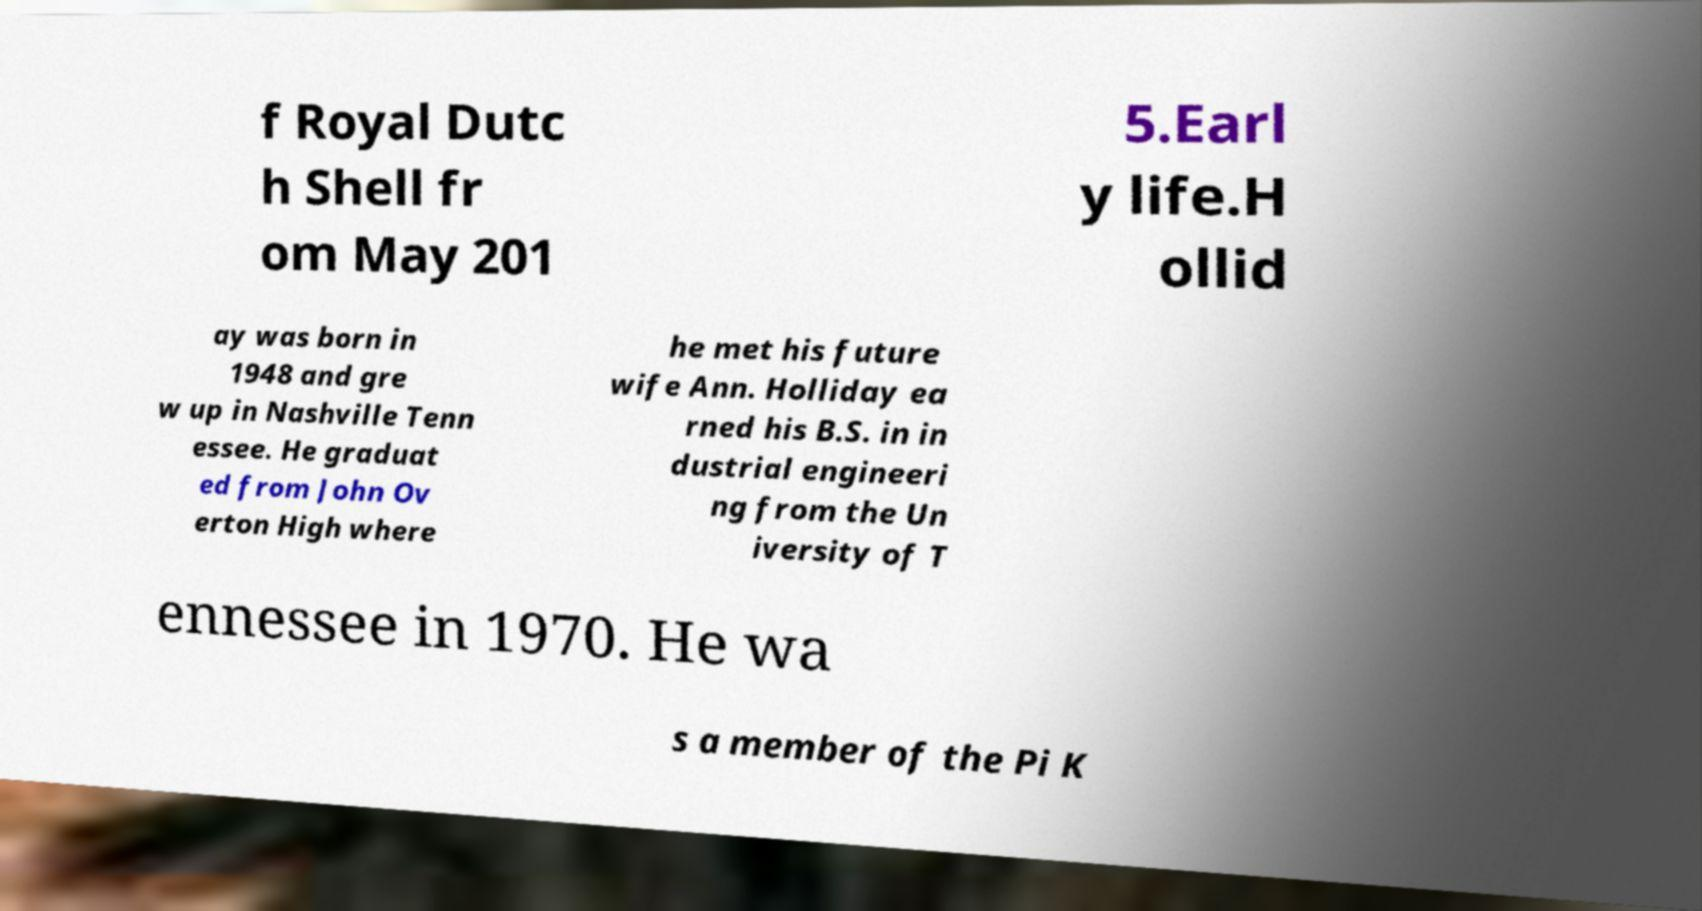Can you accurately transcribe the text from the provided image for me? f Royal Dutc h Shell fr om May 201 5.Earl y life.H ollid ay was born in 1948 and gre w up in Nashville Tenn essee. He graduat ed from John Ov erton High where he met his future wife Ann. Holliday ea rned his B.S. in in dustrial engineeri ng from the Un iversity of T ennessee in 1970. He wa s a member of the Pi K 